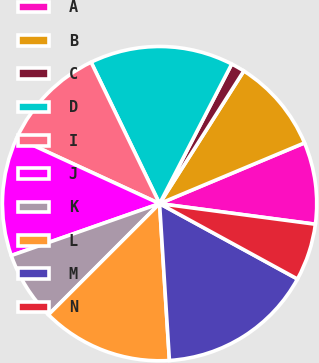Convert chart to OTSL. <chart><loc_0><loc_0><loc_500><loc_500><pie_chart><fcel>A<fcel>B<fcel>C<fcel>D<fcel>I<fcel>J<fcel>K<fcel>L<fcel>M<fcel>N<nl><fcel>8.41%<fcel>9.68%<fcel>1.41%<fcel>14.77%<fcel>10.95%<fcel>12.23%<fcel>7.14%<fcel>13.5%<fcel>16.04%<fcel>5.87%<nl></chart> 